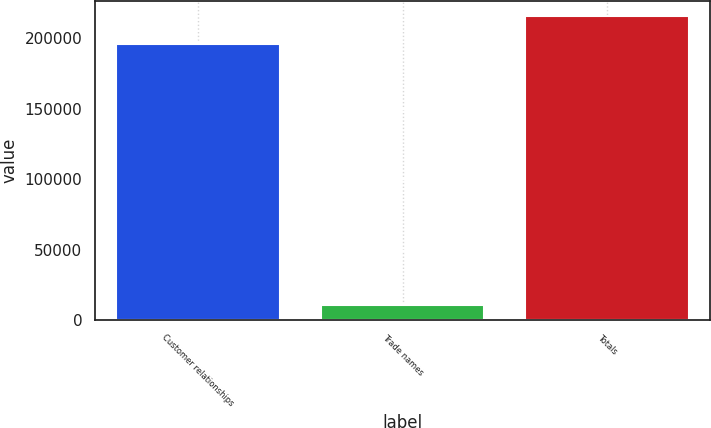Convert chart. <chart><loc_0><loc_0><loc_500><loc_500><bar_chart><fcel>Customer relationships<fcel>Trade names<fcel>Totals<nl><fcel>196328<fcel>10815<fcel>215961<nl></chart> 